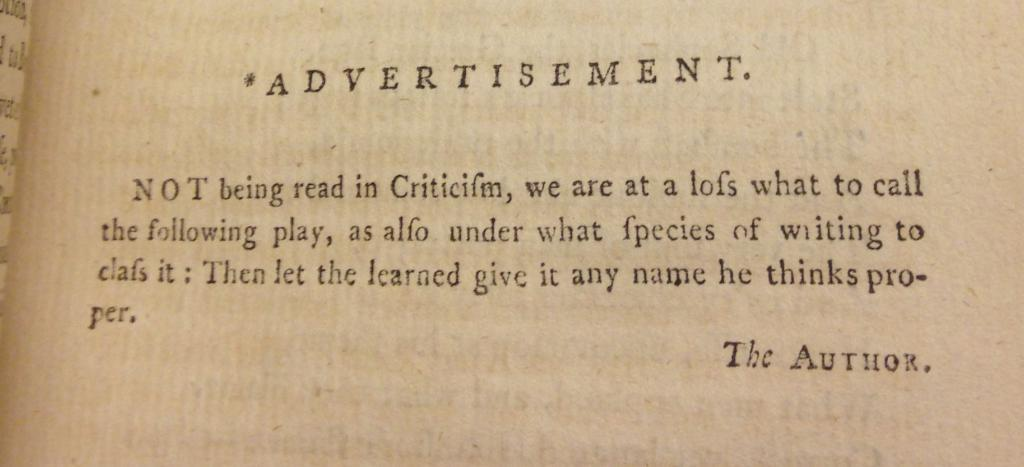<image>
Share a concise interpretation of the image provided. A yellowed paid with type has the word advertisement at the top. 